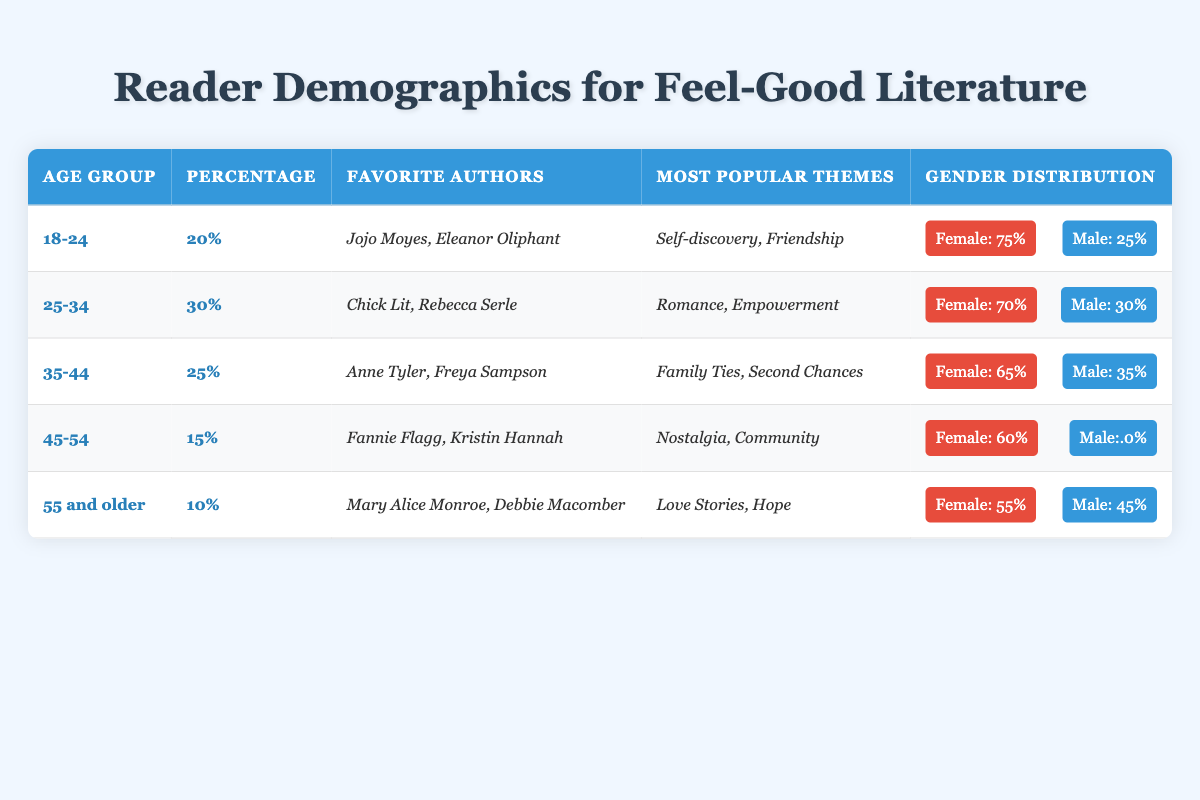What age group has the highest percentage of readers interested in feel-good literature? The highest percentage is found in the "25-34" age group, which is listed as 30%.
Answer: 25-34 What is the favorite author of the "18-24" age group? According to the table, the favorite authors for the "18-24" age group include Jojo Moyes and Eleanor Oliphant.
Answer: Jojo Moyes, Eleanor Oliphant Which age group has the lowest percentage of readers? The "55 and older" age group has the lowest percentage of readers, which is listed as 10%.
Answer: 55 and older What themes are popular among the "35-44" age group? The most popular themes for the "35-44" age group are Family Ties and Second Chances.
Answer: Family Ties, Second Chances What is the percentage of female readers in the "45-54" age group? The female percentage in the "45-54" age group is 60%, as shown in the gender distribution section.
Answer: 60% How many percentage points separate the "25-34" and "45-54" age groups? The difference in percentage points is 30% (for 25-34) - 15% (for 45-54) = 15%.
Answer: 15% Is the majority gender in the "55 and older" age group female? No, in the "55 and older" age group, the female percentage is 55%, which is the majority, so the answer is true.
Answer: Yes What is the average percentage of readers from age groups "18-24", "25-34", and "35-44"? Calculating the average: (20 + 30 + 25) / 3 = 25%.
Answer: 25% Which age group has a higher percentage of female readers, "25-34" or "35-44"? "25-34" has 70% female readers, while "35-44" has 65%, so "25-34" is higher.
Answer: 25-34 If we combine the percentages of the "45-54" and "55 and older" age groups, what is the total? Adding the percentages: 15% (for 45-54) + 10% (for 55 and older) = 25%.
Answer: 25% 